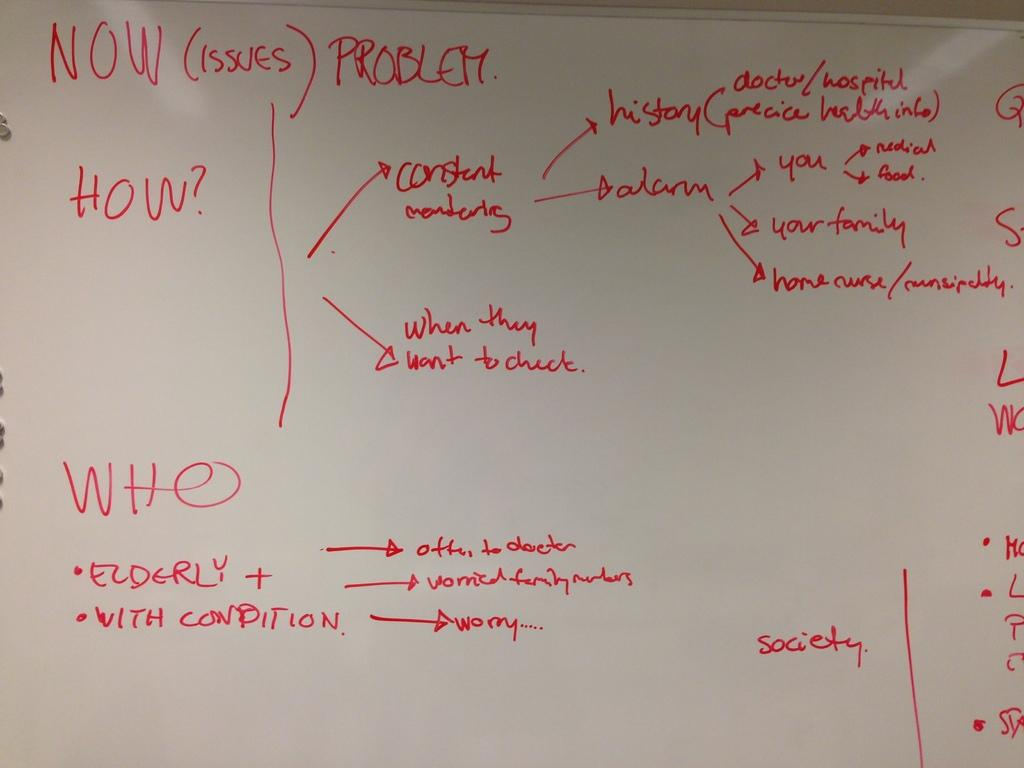<image>
Present a compact description of the photo's key features. the word Now that is on a white board 